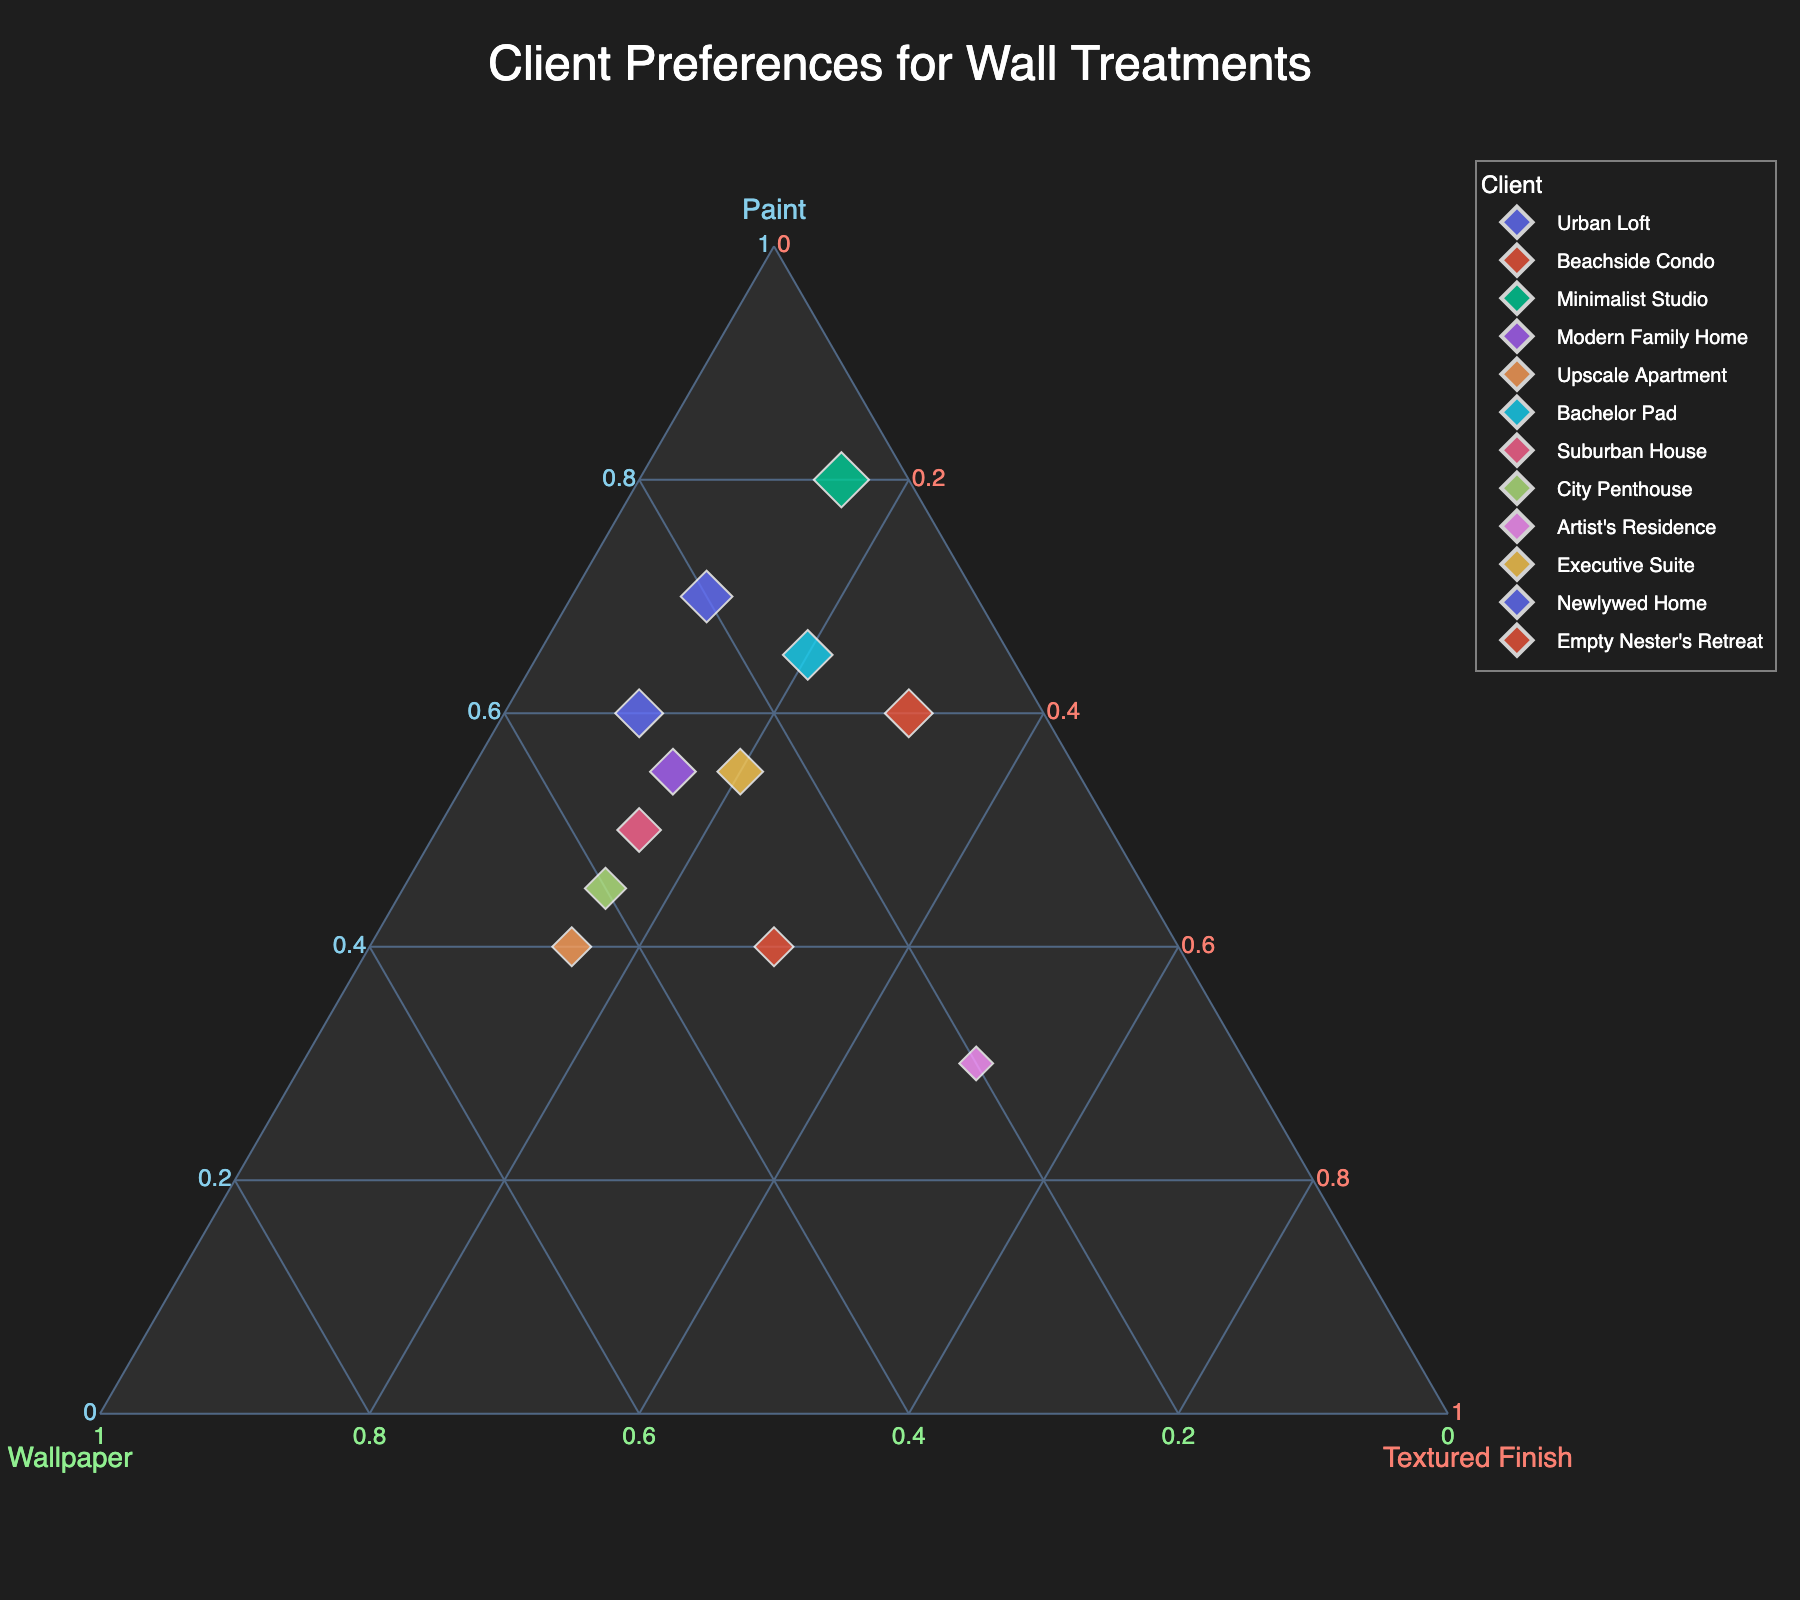What's the title of the plot? The title of the plot is centrally located at the top of the figure in a larger font size compared to the axis labels.
Answer: Client Preferences for Wall Treatments What client has the highest percentage for paint? By looking at the points in the ternary plot and noting the percentages along the paint axis, the point that reaches the highest on the paint axis belongs to the "Minimalist Studio".
Answer: Minimalist Studio Which clients prefer wallpaper over paint? By examining the data points along both the wallpaper and paint axes, we see that any point closer to the wallpaper axis than the paint axis fits this criterion. "Upscale Apartment" is one such client.
Answer: Upscale Apartment Which clients have equal percentages for wallpaper and textured finishes? By identifying points that are equidistant from both the wallpaper and textured finish axes, we find "Empty Nester's Retreat" has equal percentages for wallpaper and textured finishes.
Answer: Empty Nester's Retreat What's the combined percentage of paint and wallpaper for "Modern Family Home"? Summing the values for paint and wallpaper for "Modern Family Home" from the plot: 55 (paint) + 30 (wallpaper) = 85.
Answer: 85 Between "Beachside Condo" and "Artist's Residence," which client has a higher preference for textured finishes? Comparing the positions of these clients along the textured finish axis, "Artist's Residence" has a higher percentage there.
Answer: Artist's Residence How many clients have a preference for paint above 60%? By identifying the data points that lie beyond the 60% mark on the paint axis, we find four clients: "Urban Loft", "Beachside Condo", "Minimalist Studio", and "Newlywed Home".
Answer: 4 What's the average percentage of wallpaper among all clients? Adding up the wallpaper percentages for all clients and dividing by the number of clients: (20 + 10 + 5 + 30 + 45 + 15 + 35 + 40 + 20 + 25 + 30 + 30) / 12 = 305 /12 ≈ 25.42.
Answer: 25.42 Which client is the closest to having equal percentages in all three categories? The client nearest the center of the ternary plot equidistant from all three axes is "Empty Nester's Retreat".
Answer: Empty Nester's Retreat 